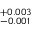Convert formula to latex. <formula><loc_0><loc_0><loc_500><loc_500>^ { + 0 . 0 0 3 } _ { - 0 . 0 0 1 }</formula> 